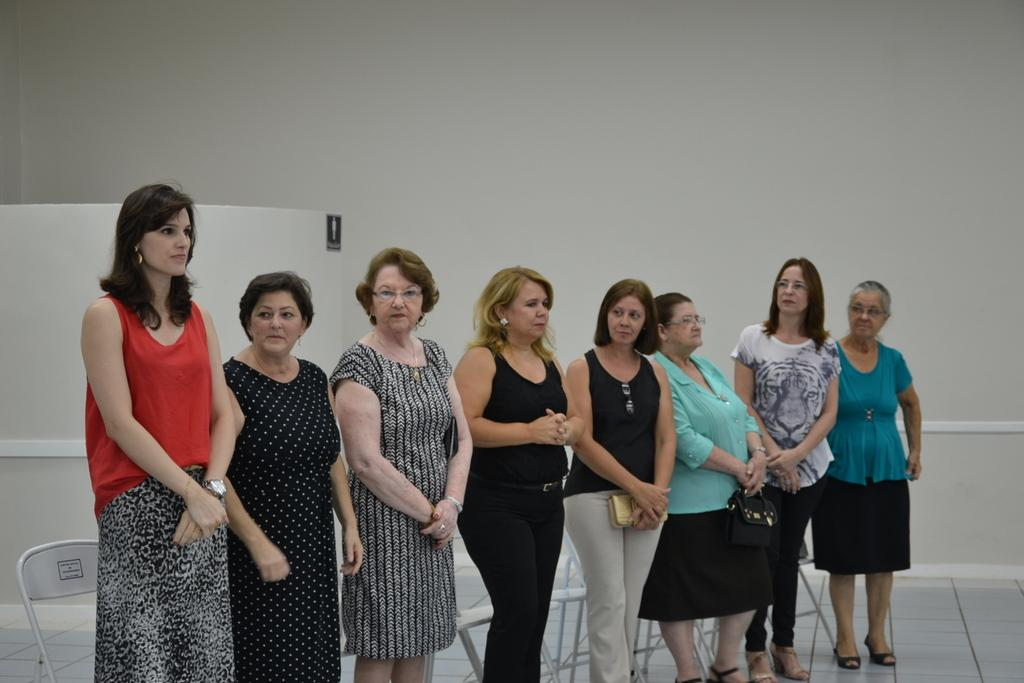What is happening in the center of the image? There is a group of people standing in the center of the image. What can be seen in the background of the image? There are chairs and a wall in the background of the image. What is visible at the bottom of the image? The floor is visible at the bottom of the image. What type of behavior is being discussed at the meeting in the image? There is no meeting present in the image, so it is not possible to determine what type of behavior is being discussed. 